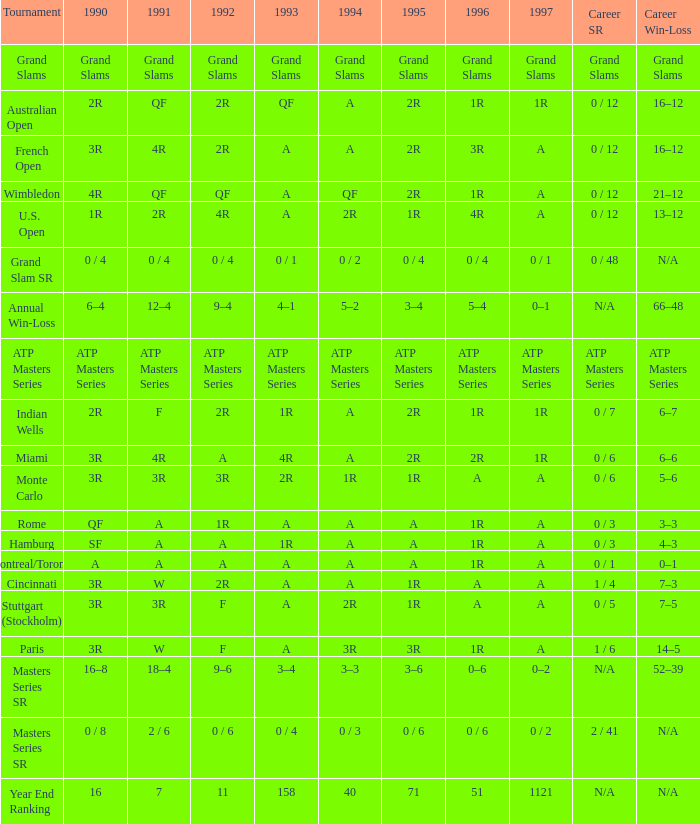Given that "1r" is 1996, "2r" is 1990, and "f" is 1991, what would be the representation for 1997? 1R. 